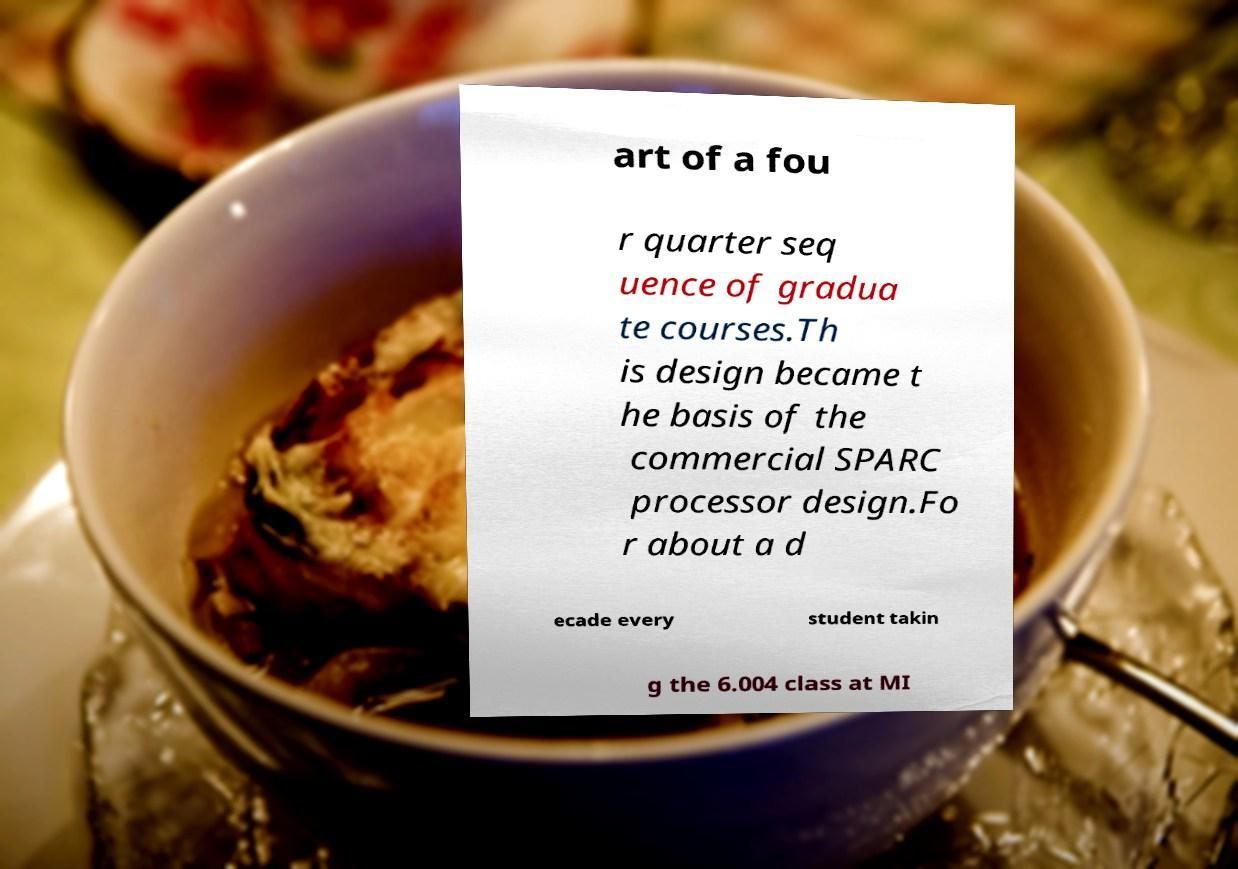For documentation purposes, I need the text within this image transcribed. Could you provide that? art of a fou r quarter seq uence of gradua te courses.Th is design became t he basis of the commercial SPARC processor design.Fo r about a d ecade every student takin g the 6.004 class at MI 